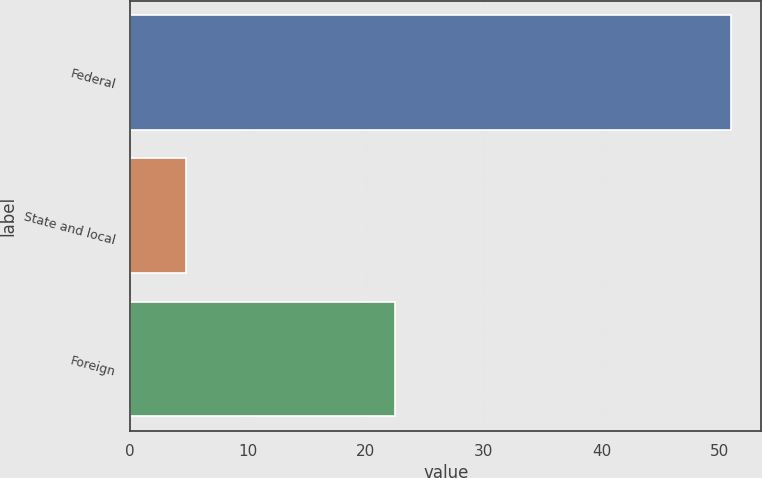<chart> <loc_0><loc_0><loc_500><loc_500><bar_chart><fcel>Federal<fcel>State and local<fcel>Foreign<nl><fcel>51<fcel>4.7<fcel>22.5<nl></chart> 